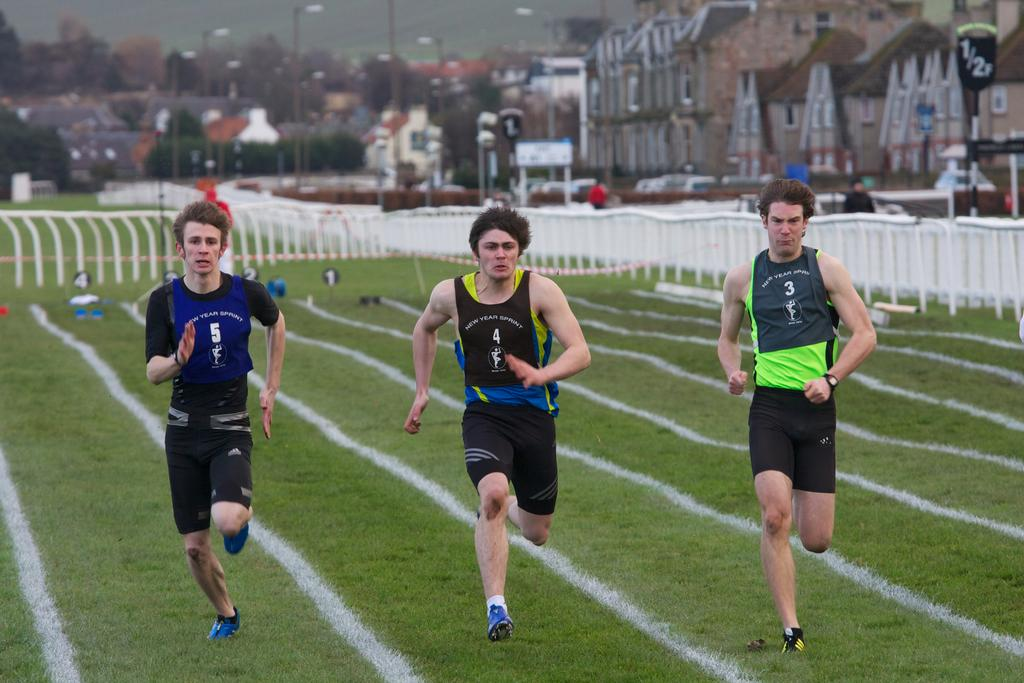<image>
Give a short and clear explanation of the subsequent image. Three runners with 5, 4, and 3 on their shirts. 